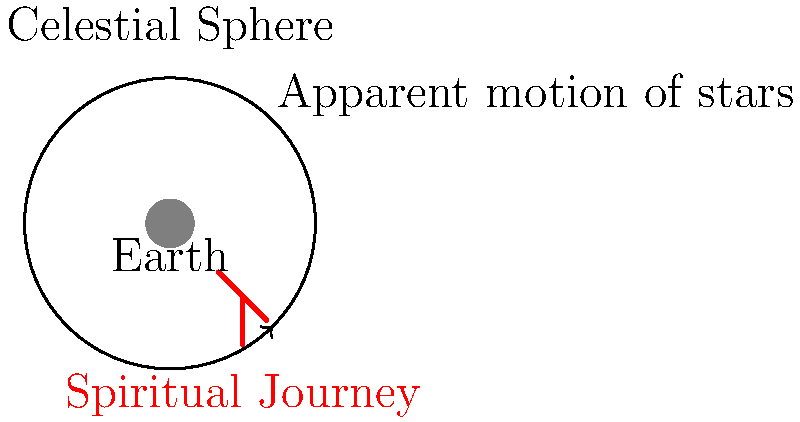In religious paintings, the apparent motion of stars in the night sky is often used as a metaphor for spiritual journey. What celestial phenomenon causes this apparent motion, and how does it relate to the Earth's rotation? 1. The apparent motion of stars in the night sky is caused by the Earth's rotation on its axis.

2. As the Earth rotates from west to east, stars appear to move from east to west across the night sky.

3. This rotation takes approximately 24 hours to complete one full cycle.

4. From an observer's perspective on Earth, the stars seem to revolve around a fixed point in the sky called the celestial pole.

5. In the Northern Hemisphere, this point is near the North Star (Polaris), while in the Southern Hemisphere, it's near the Southern Cross.

6. The path of stars appears circular because we are observing from a rotating sphere (Earth) looking out at a seemingly stationary celestial sphere.

7. In religious paintings, this circular motion is often used to symbolize:
   a) The cyclical nature of life and spiritual growth
   b) The journey of the soul towards God or enlightenment
   c) The constancy of God's presence (represented by the fixed celestial pole) amidst life's changes

8. The metaphor works because, like a spiritual journey, the stars' motion is:
   a) Constant and predictable
   b) Circular, suggesting completion or perfection
   c) Centered around a fixed point, symbolizing an ultimate goal or divine presence

9. Artists often incorporate this symbolism by depicting circular patterns, spirals, or star-like elements in religious artwork to evoke the idea of spiritual progression and divine guidance.
Answer: Earth's rotation causes apparent star motion; symbolizes spiritual journey in art. 